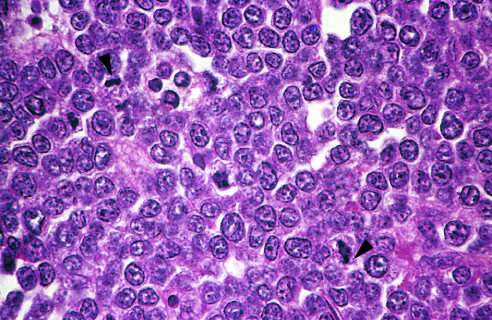what are fairly uniform, giving a monotonous appearance?
Answer the question using a single word or phrase. The tumor cells and their nuclei 